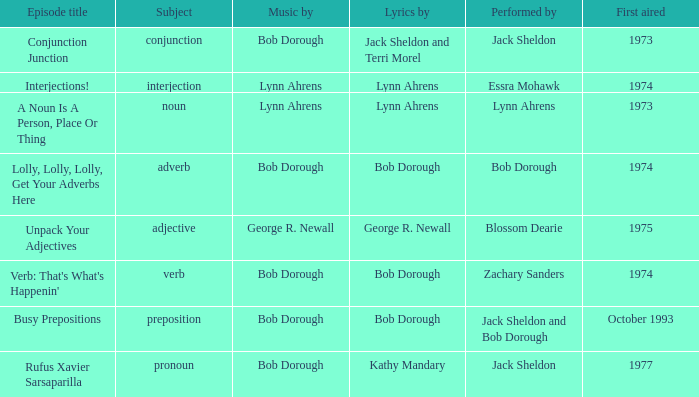When interjection is the subject how many performers are there? 1.0. 